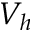Convert formula to latex. <formula><loc_0><loc_0><loc_500><loc_500>V _ { h }</formula> 